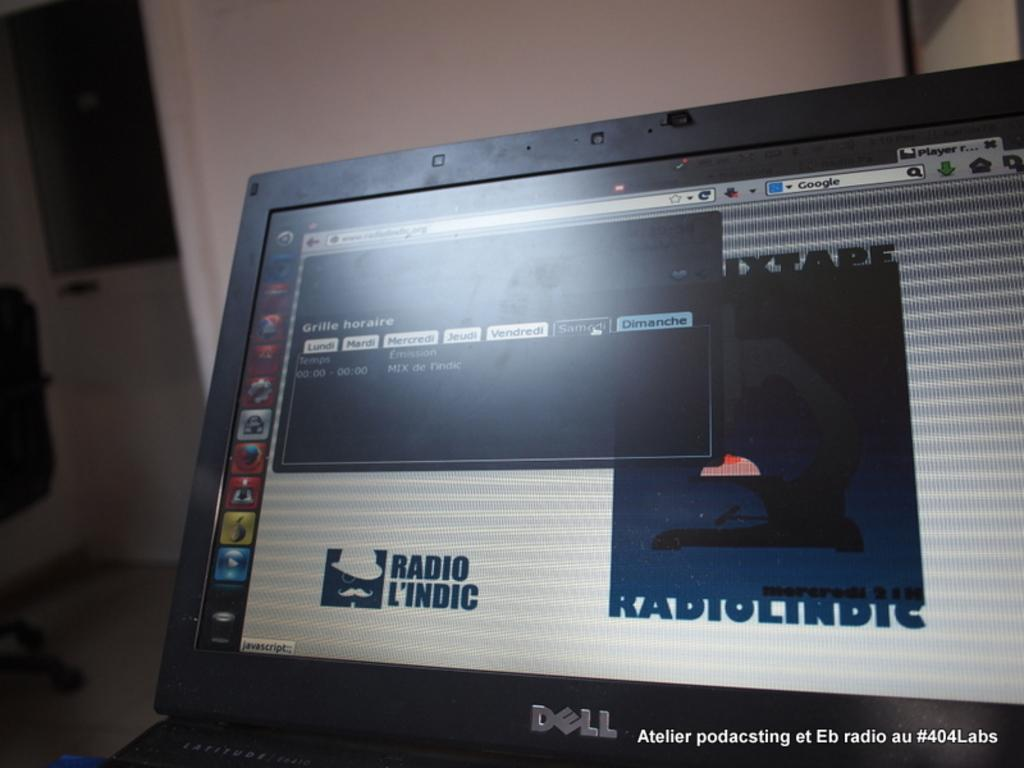<image>
Give a short and clear explanation of the subsequent image. A computer screen by Dell has the words Radio L'Indic on it. 